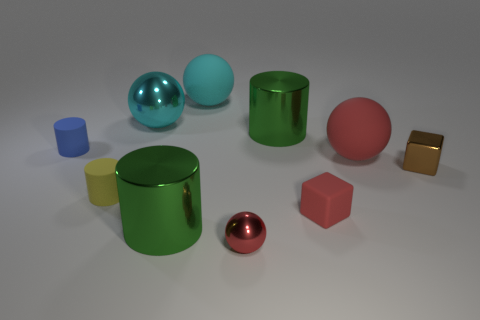Subtract all cylinders. How many objects are left? 6 Subtract 0 brown spheres. How many objects are left? 10 Subtract all cyan objects. Subtract all shiny things. How many objects are left? 3 Add 9 brown cubes. How many brown cubes are left? 10 Add 4 tiny brown cubes. How many tiny brown cubes exist? 5 